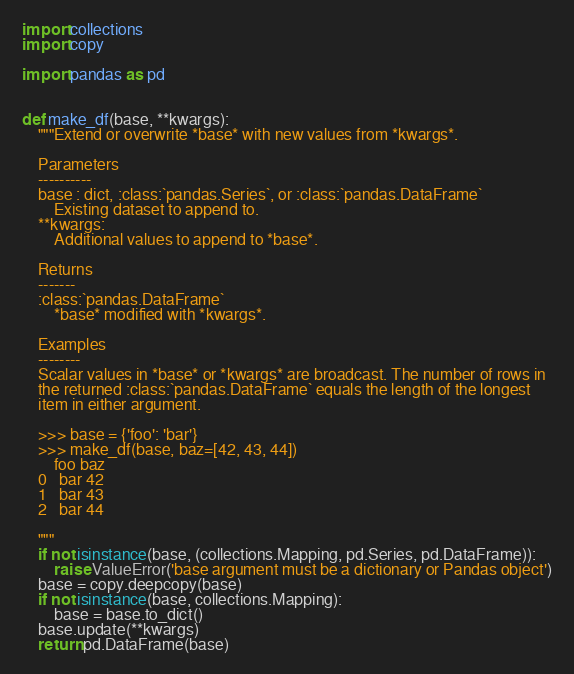Convert code to text. <code><loc_0><loc_0><loc_500><loc_500><_Python_>import collections
import copy

import pandas as pd


def make_df(base, **kwargs):
    """Extend or overwrite *base* with new values from *kwargs*.

    Parameters
    ----------
    base : dict, :class:`pandas.Series`, or :class:`pandas.DataFrame`
        Existing dataset to append to.
    **kwargs:
        Additional values to append to *base*.

    Returns
    -------
    :class:`pandas.DataFrame`
        *base* modified with *kwargs*.

    Examples
    --------
    Scalar values in *base* or *kwargs* are broadcast. The number of rows in
    the returned :class:`pandas.DataFrame` equals the length of the longest
    item in either argument.

    >>> base = {'foo': 'bar'}
    >>> make_df(base, baz=[42, 43, 44])
        foo	baz
    0	bar	42
    1	bar	43
    2	bar	44

    """
    if not isinstance(base, (collections.Mapping, pd.Series, pd.DataFrame)):
        raise ValueError('base argument must be a dictionary or Pandas object')
    base = copy.deepcopy(base)
    if not isinstance(base, collections.Mapping):
        base = base.to_dict()
    base.update(**kwargs)
    return pd.DataFrame(base)
</code> 